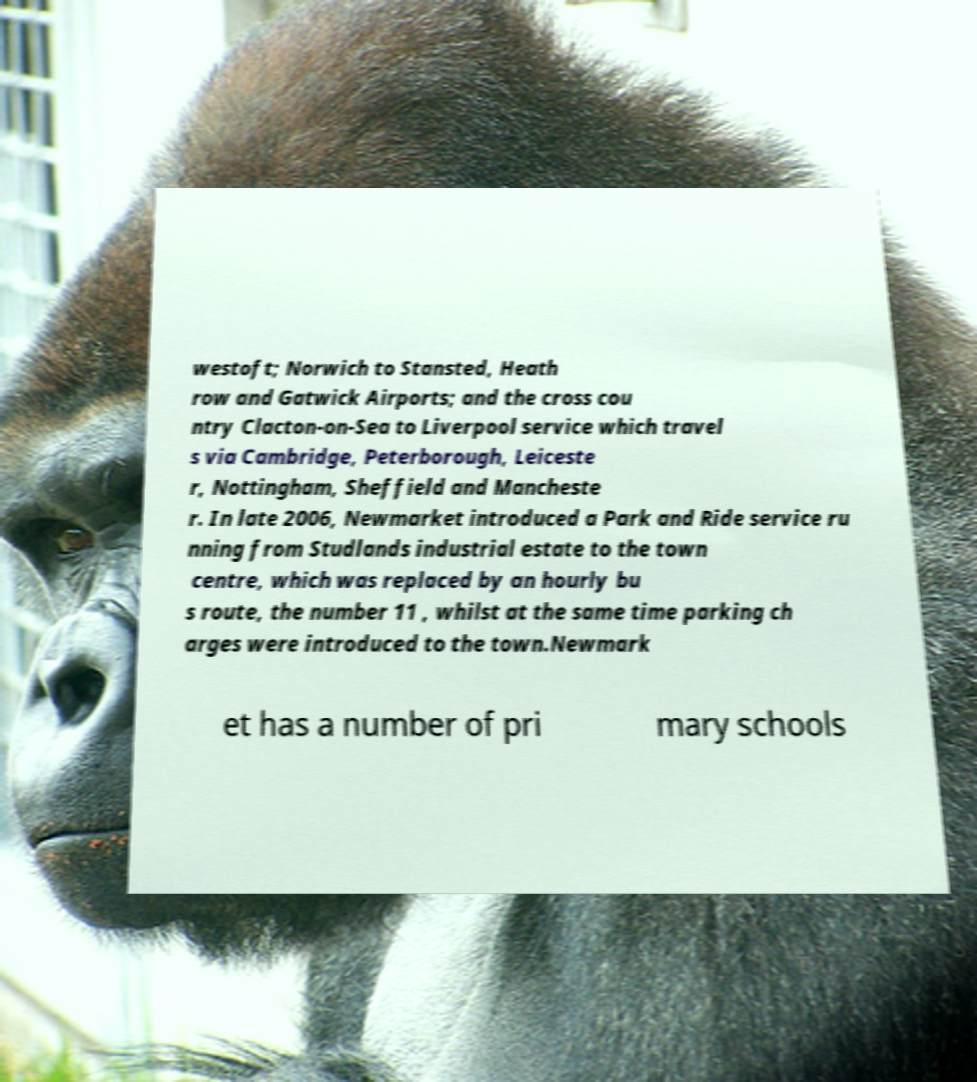Could you extract and type out the text from this image? westoft; Norwich to Stansted, Heath row and Gatwick Airports; and the cross cou ntry Clacton-on-Sea to Liverpool service which travel s via Cambridge, Peterborough, Leiceste r, Nottingham, Sheffield and Mancheste r. In late 2006, Newmarket introduced a Park and Ride service ru nning from Studlands industrial estate to the town centre, which was replaced by an hourly bu s route, the number 11 , whilst at the same time parking ch arges were introduced to the town.Newmark et has a number of pri mary schools 